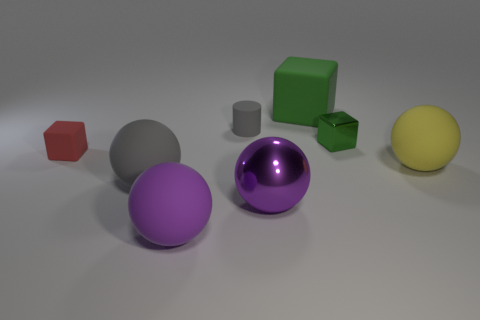Subtract all gray spheres. Subtract all yellow blocks. How many spheres are left? 3 Add 1 green metal objects. How many objects exist? 9 Subtract all cubes. How many objects are left? 5 Add 5 small red rubber cubes. How many small red rubber cubes are left? 6 Add 5 large gray matte balls. How many large gray matte balls exist? 6 Subtract 1 green blocks. How many objects are left? 7 Subtract all gray matte cylinders. Subtract all tiny green metal cubes. How many objects are left? 6 